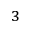<formula> <loc_0><loc_0><loc_500><loc_500>_ { 3 }</formula> 